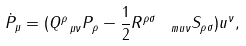<formula> <loc_0><loc_0><loc_500><loc_500>\dot { P } _ { \mu } = ( Q ^ { \rho } _ { \ \mu \nu } P _ { \rho } - \frac { 1 } { 2 } R ^ { \rho \sigma } _ { \quad m u \nu } S _ { \rho \sigma } ) u ^ { \nu } ,</formula> 